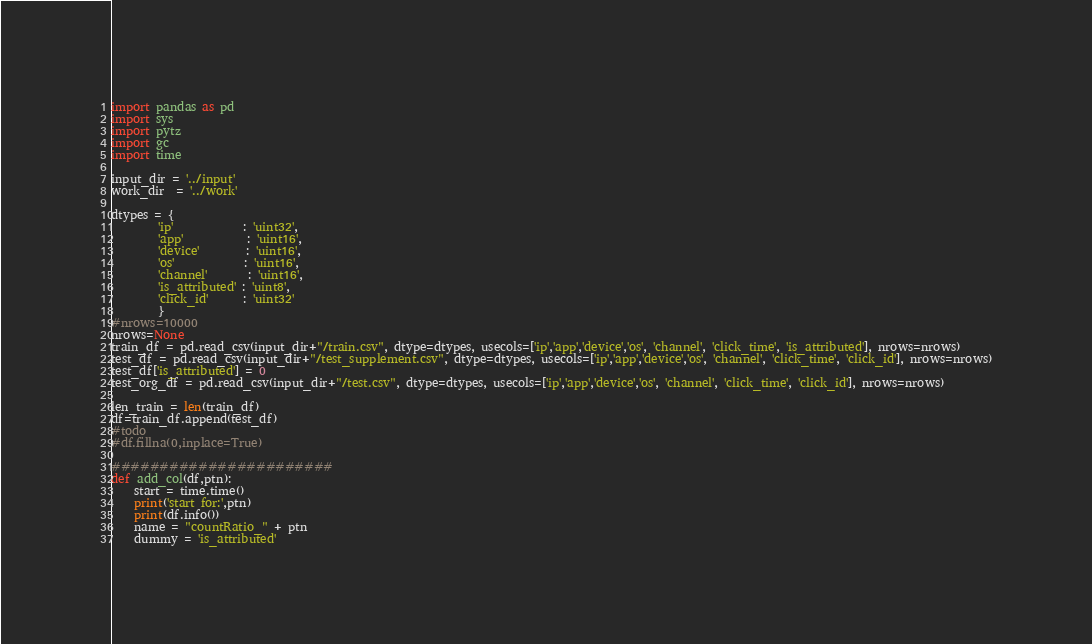<code> <loc_0><loc_0><loc_500><loc_500><_Python_>import pandas as pd
import sys
import pytz
import gc
import time

input_dir = '../input'
work_dir  = '../work'

dtypes = {
        'ip'            : 'uint32',
        'app'           : 'uint16',
        'device'        : 'uint16',
        'os'            : 'uint16',
        'channel'       : 'uint16',
        'is_attributed' : 'uint8',
        'click_id'      : 'uint32'
        }
#nrows=10000
nrows=None
train_df = pd.read_csv(input_dir+"/train.csv", dtype=dtypes, usecols=['ip','app','device','os', 'channel', 'click_time', 'is_attributed'], nrows=nrows)
test_df = pd.read_csv(input_dir+"/test_supplement.csv", dtype=dtypes, usecols=['ip','app','device','os', 'channel', 'click_time', 'click_id'], nrows=nrows)
test_df['is_attributed'] = 0
test_org_df = pd.read_csv(input_dir+"/test.csv", dtype=dtypes, usecols=['ip','app','device','os', 'channel', 'click_time', 'click_id'], nrows=nrows)

len_train = len(train_df)
df=train_df.append(test_df)
#todo
#df.fillna(0,inplace=True)

#######################
def add_col(df,ptn):
    start = time.time()
    print('start for:',ptn)
    print(df.info())
    name = "countRatio_" + ptn
    dummy = 'is_attributed'</code> 